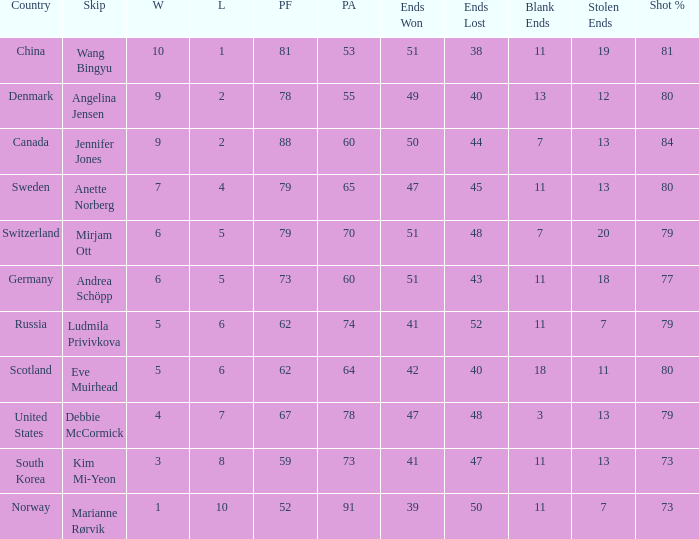What is norway's smallest ends misplaced? 50.0. 